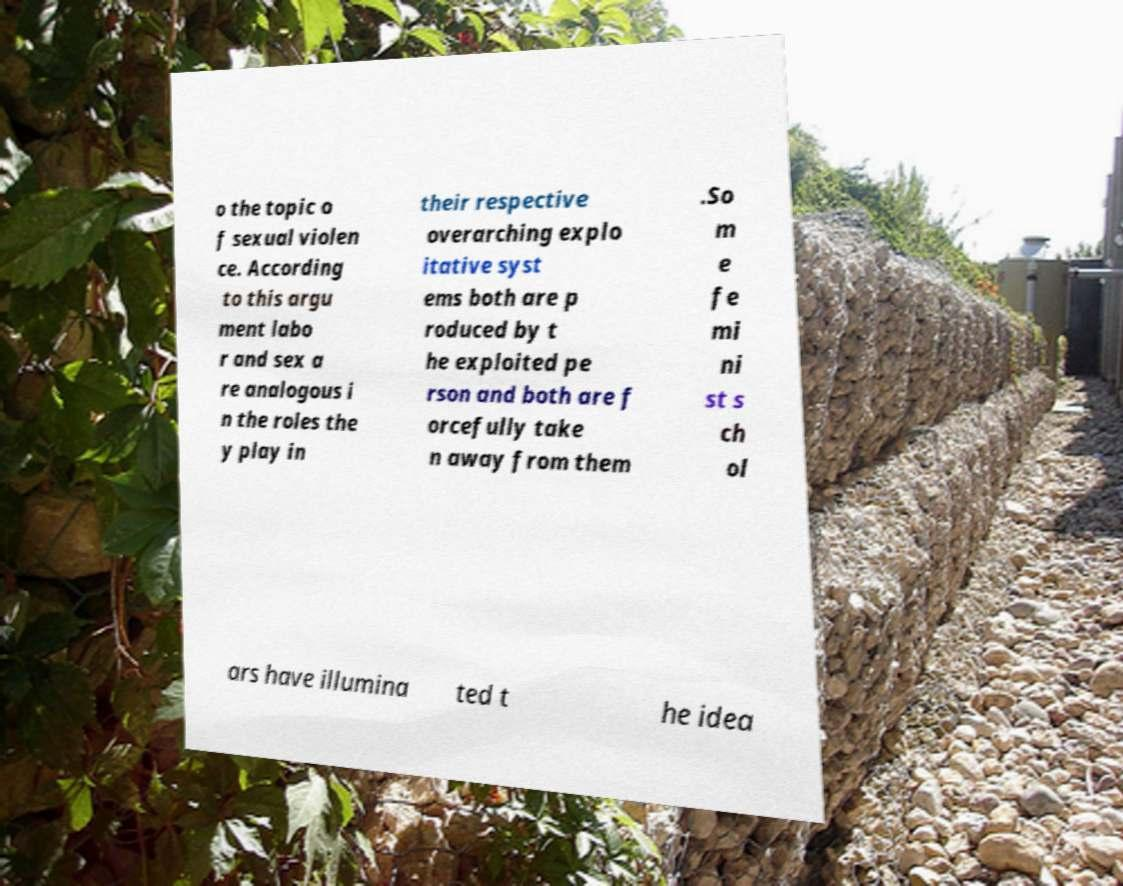What messages or text are displayed in this image? I need them in a readable, typed format. o the topic o f sexual violen ce. According to this argu ment labo r and sex a re analogous i n the roles the y play in their respective overarching explo itative syst ems both are p roduced by t he exploited pe rson and both are f orcefully take n away from them .So m e fe mi ni st s ch ol ars have illumina ted t he idea 